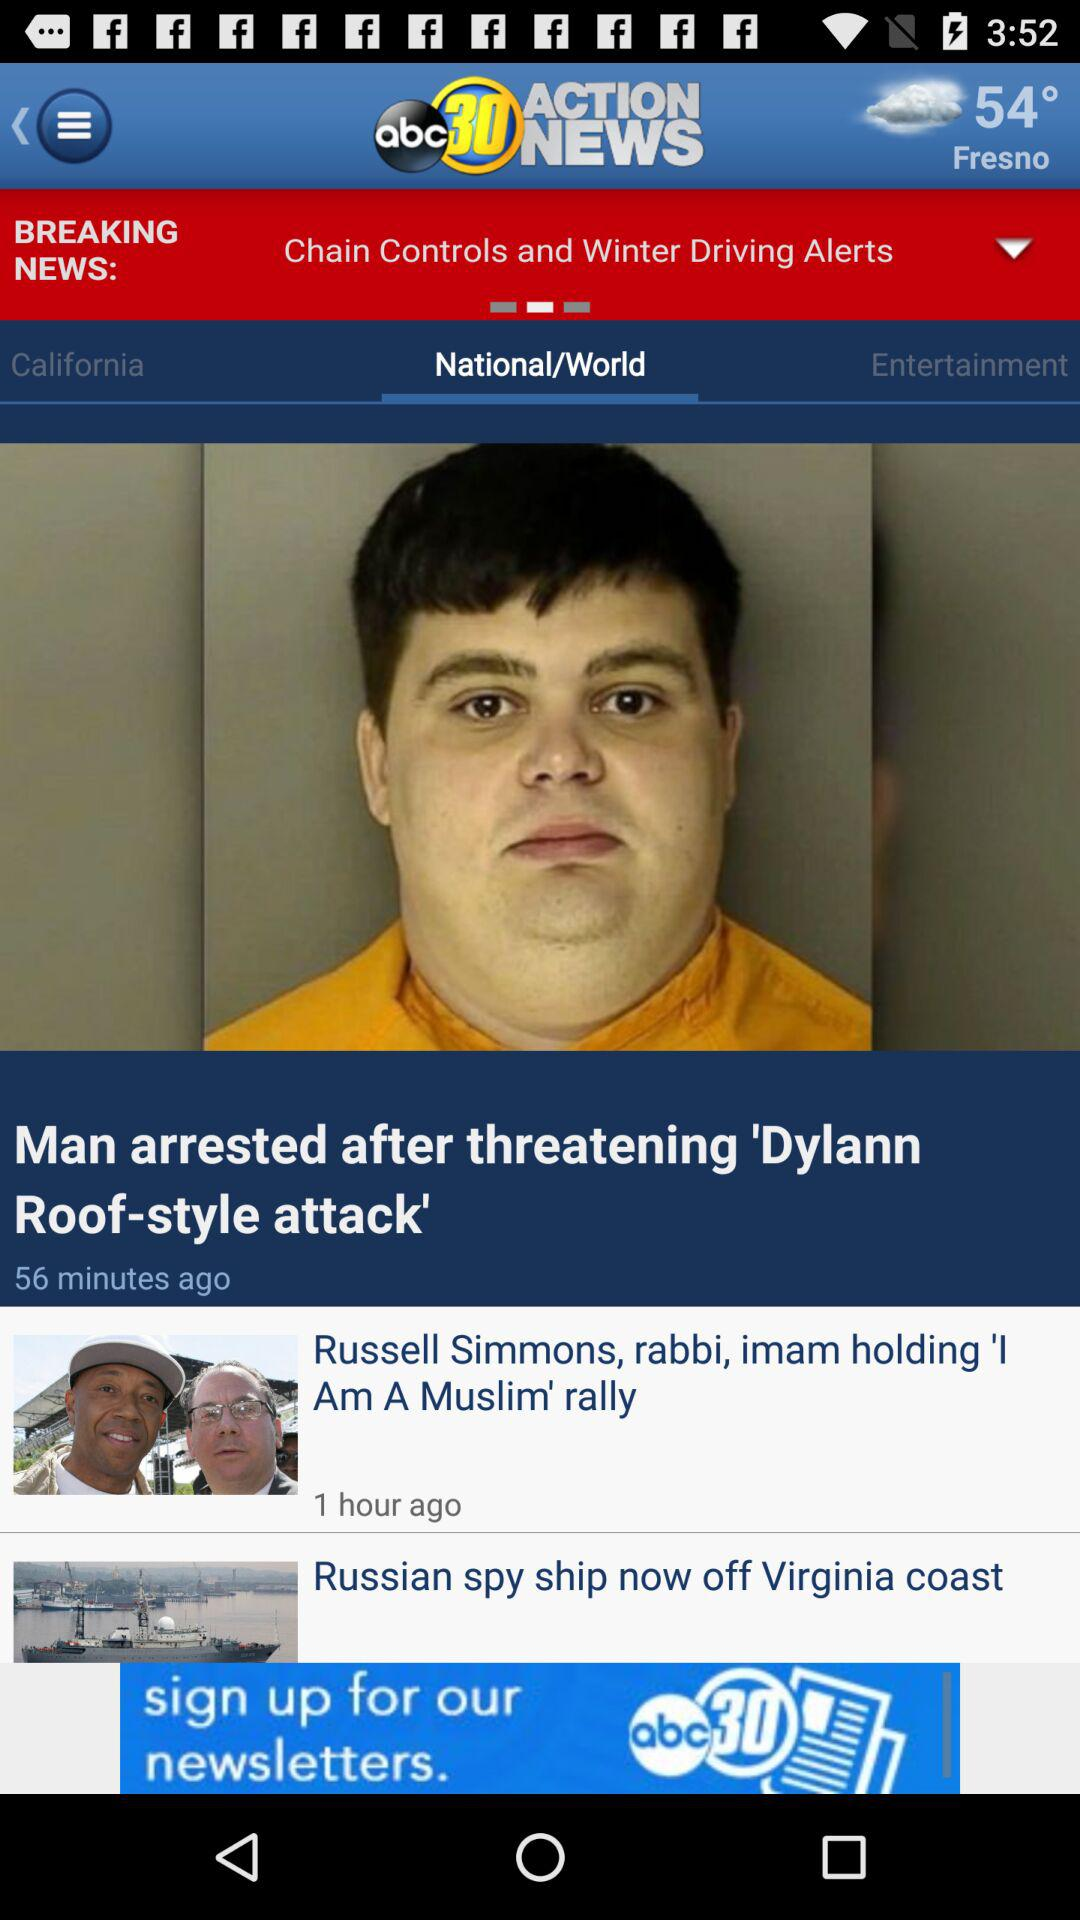What is the breaking news shown? The breaking news shown is "Chain Controls and Winter Driving Alerts". 